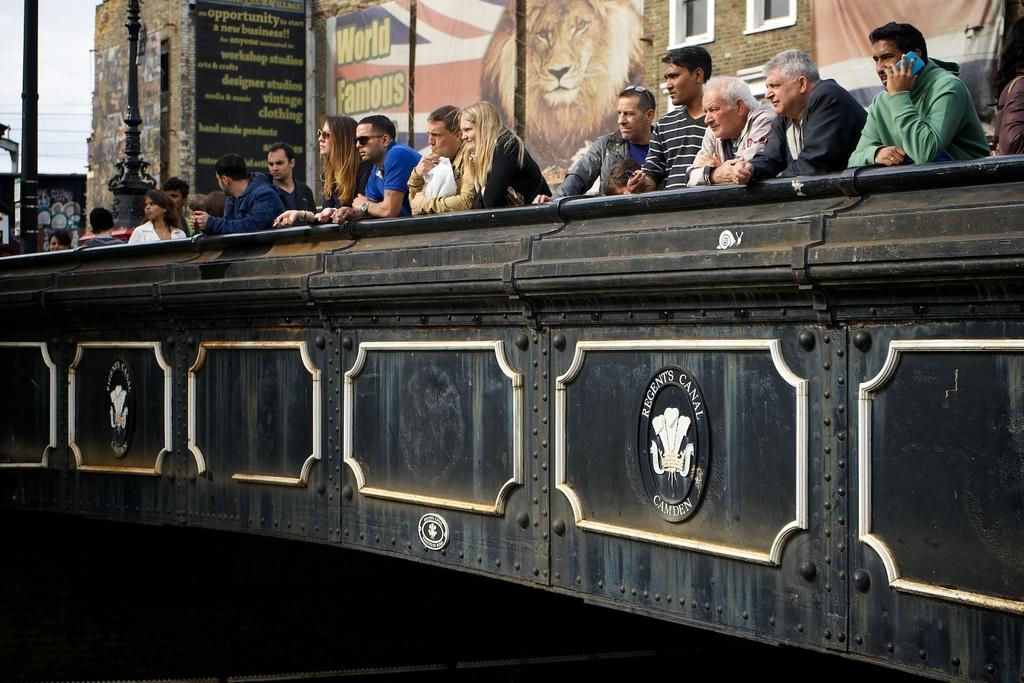<image>
Share a concise interpretation of the image provided. People sitting behind a booth which says Regent's Canal on it. 